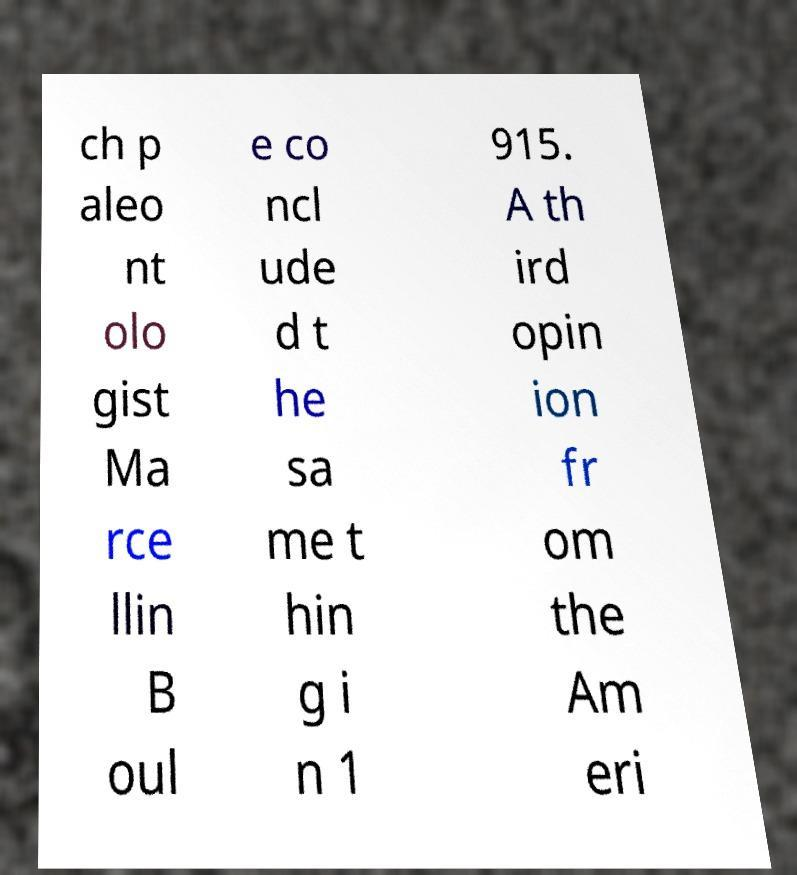I need the written content from this picture converted into text. Can you do that? ch p aleo nt olo gist Ma rce llin B oul e co ncl ude d t he sa me t hin g i n 1 915. A th ird opin ion fr om the Am eri 